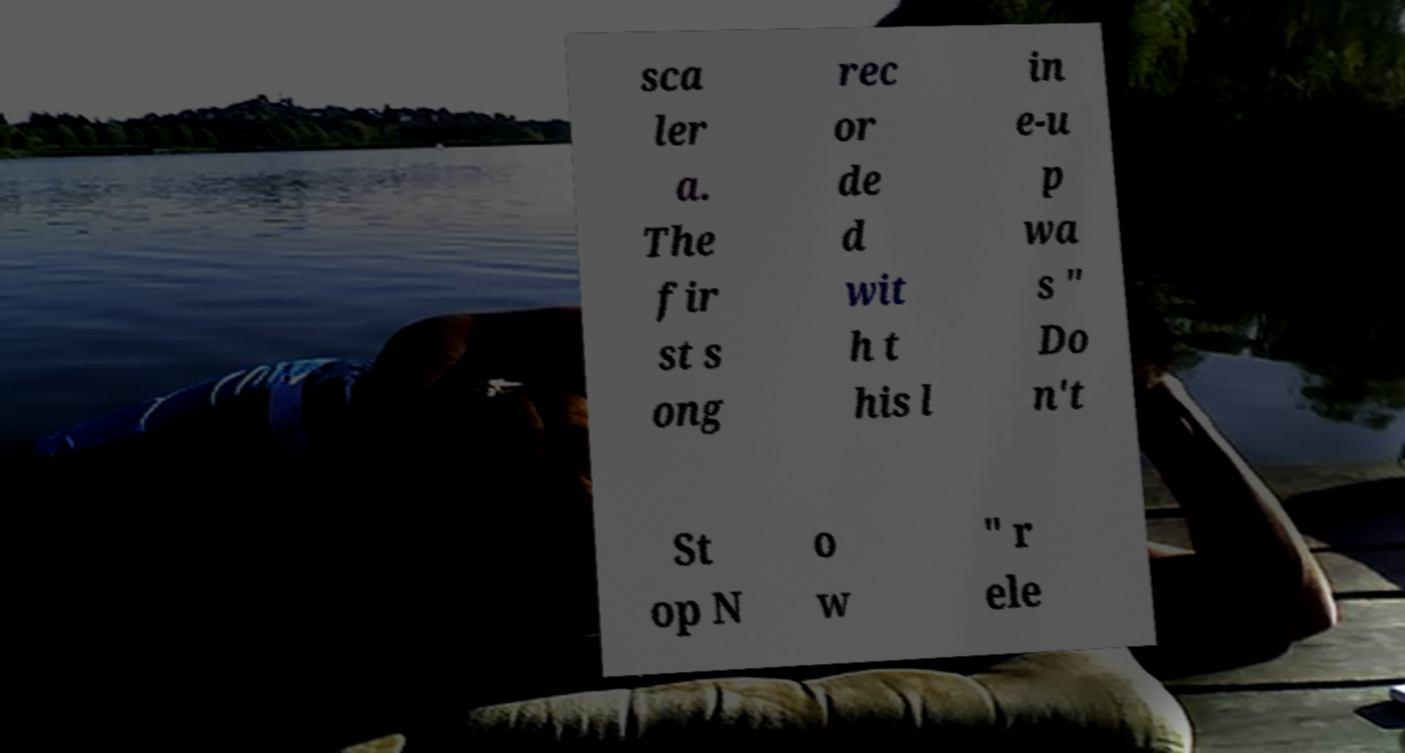I need the written content from this picture converted into text. Can you do that? sca ler a. The fir st s ong rec or de d wit h t his l in e-u p wa s " Do n't St op N o w " r ele 